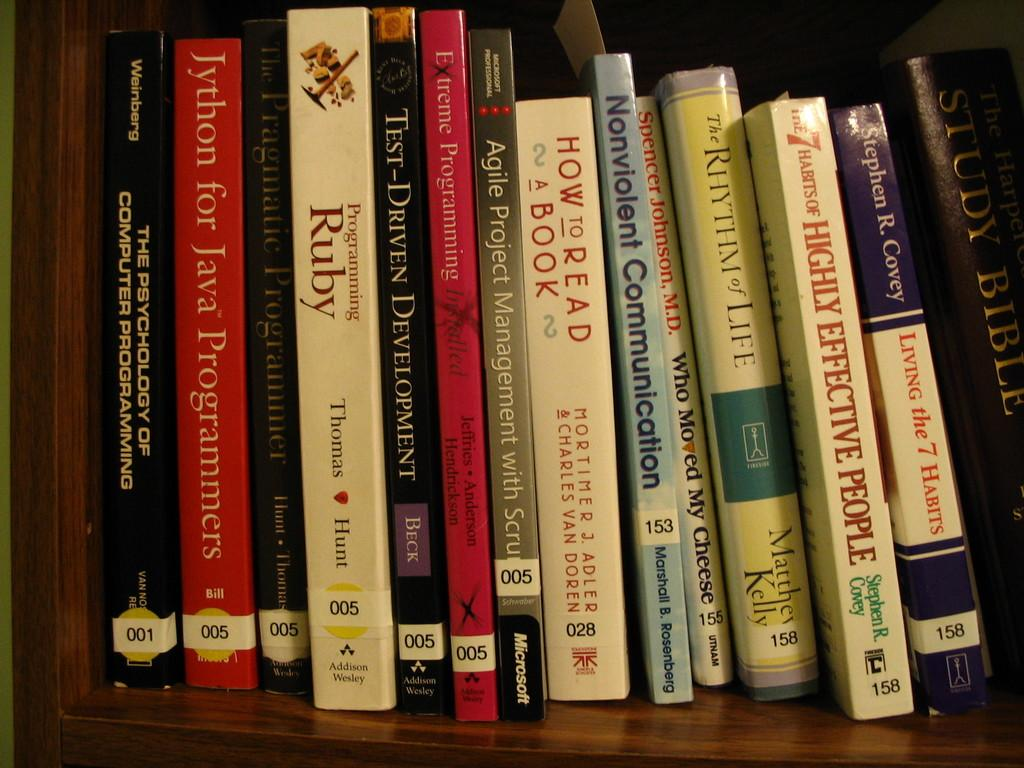<image>
Relay a brief, clear account of the picture shown. a book called How to Read a Book sits with other books on a shelf. 